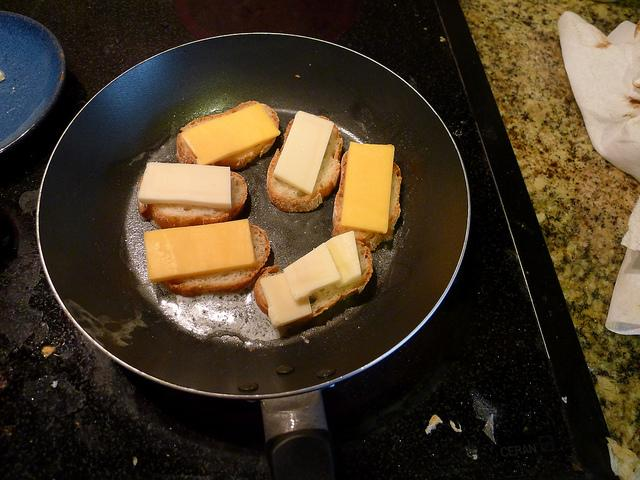What will happen to the yellow and white slices? melt 